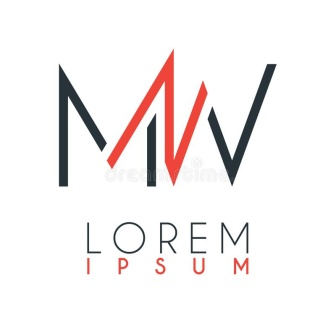Write a detailed description of the given image. The image exhibits an elegant and minimalist logo design, presumably for a brand named 'Lorem Ipsum.' The core graphic feature is an overlapping of two letters, 'M' and 'W,' stylized with sharp angles and lines. The 'M' is depicted in a sleek black, while the 'W' is in a bold red, creating a striking contrast and a sense of balance. The name of the company, 'Lorem Ipsum,' is situated below the letters, using the same color scheme to further emphasize the brand's visual identity. The font chosen for the text is modern and sans-serif, complementing the contemporary feel of the logo. The simplicity of the design lends itself to versatility, likely making it easily recognizable and adaptable across various mediums. 